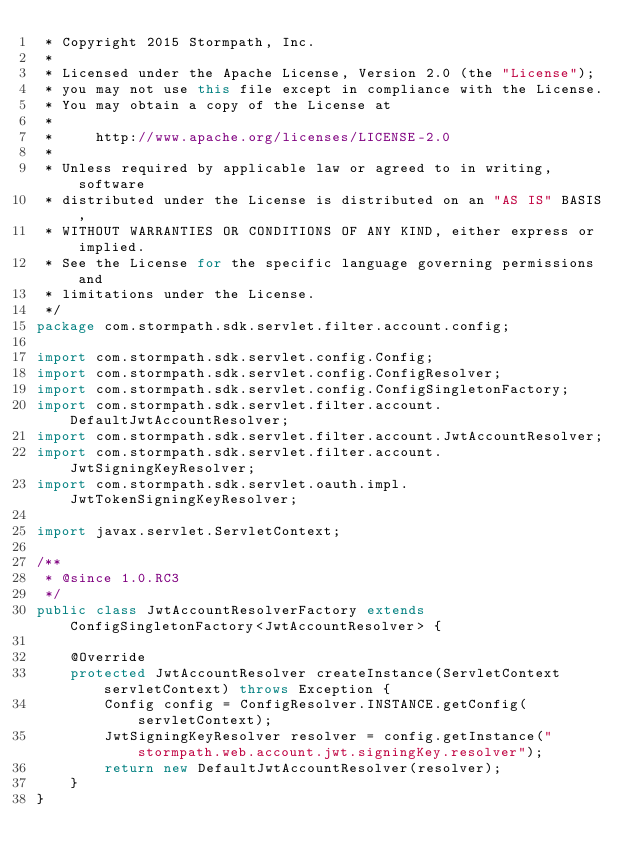Convert code to text. <code><loc_0><loc_0><loc_500><loc_500><_Java_> * Copyright 2015 Stormpath, Inc.
 *
 * Licensed under the Apache License, Version 2.0 (the "License");
 * you may not use this file except in compliance with the License.
 * You may obtain a copy of the License at
 *
 *     http://www.apache.org/licenses/LICENSE-2.0
 *
 * Unless required by applicable law or agreed to in writing, software
 * distributed under the License is distributed on an "AS IS" BASIS,
 * WITHOUT WARRANTIES OR CONDITIONS OF ANY KIND, either express or implied.
 * See the License for the specific language governing permissions and
 * limitations under the License.
 */
package com.stormpath.sdk.servlet.filter.account.config;

import com.stormpath.sdk.servlet.config.Config;
import com.stormpath.sdk.servlet.config.ConfigResolver;
import com.stormpath.sdk.servlet.config.ConfigSingletonFactory;
import com.stormpath.sdk.servlet.filter.account.DefaultJwtAccountResolver;
import com.stormpath.sdk.servlet.filter.account.JwtAccountResolver;
import com.stormpath.sdk.servlet.filter.account.JwtSigningKeyResolver;
import com.stormpath.sdk.servlet.oauth.impl.JwtTokenSigningKeyResolver;

import javax.servlet.ServletContext;

/**
 * @since 1.0.RC3
 */
public class JwtAccountResolverFactory extends ConfigSingletonFactory<JwtAccountResolver> {

    @Override
    protected JwtAccountResolver createInstance(ServletContext servletContext) throws Exception {
        Config config = ConfigResolver.INSTANCE.getConfig(servletContext);
        JwtSigningKeyResolver resolver = config.getInstance("stormpath.web.account.jwt.signingKey.resolver");
        return new DefaultJwtAccountResolver(resolver);
    }
}
</code> 